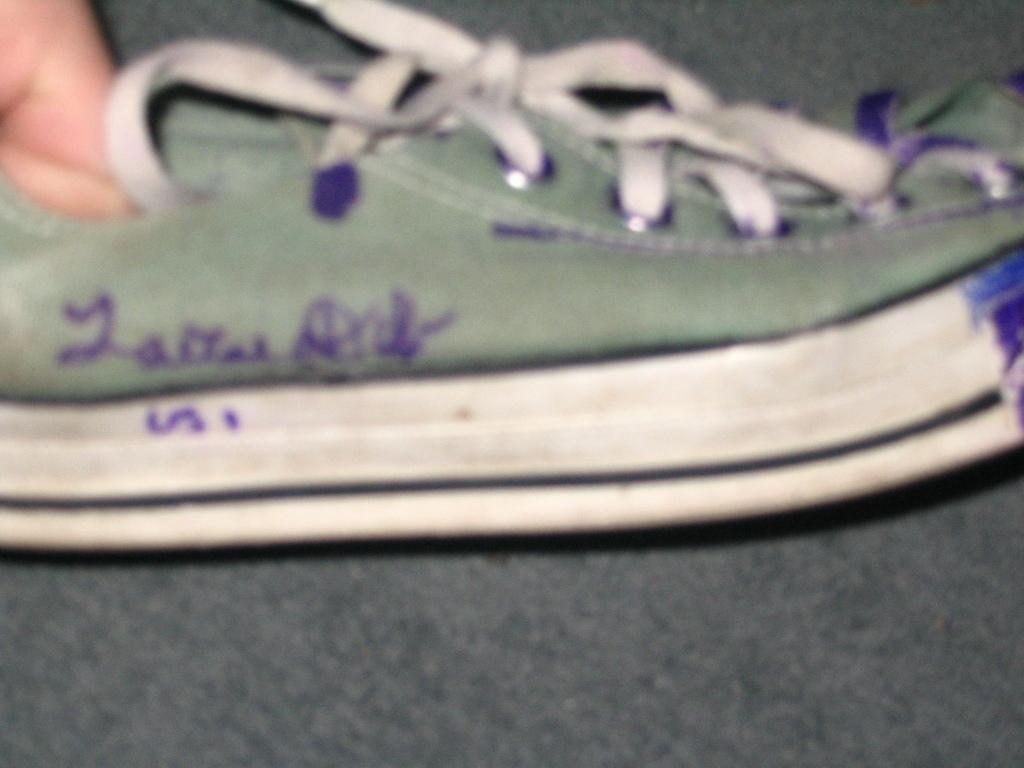What object can be seen in the image? There is a shoe in the image. Can you identify any body parts in the image? A person's hand is visible in the image. What type of operation is being performed on the shoe in the image? There is no operation being performed on the shoe in the image; it is simply a shoe and a hand visible. What color of ink is being used to write on the shoe in the image? There is no ink or writing present on the shoe in the image. 